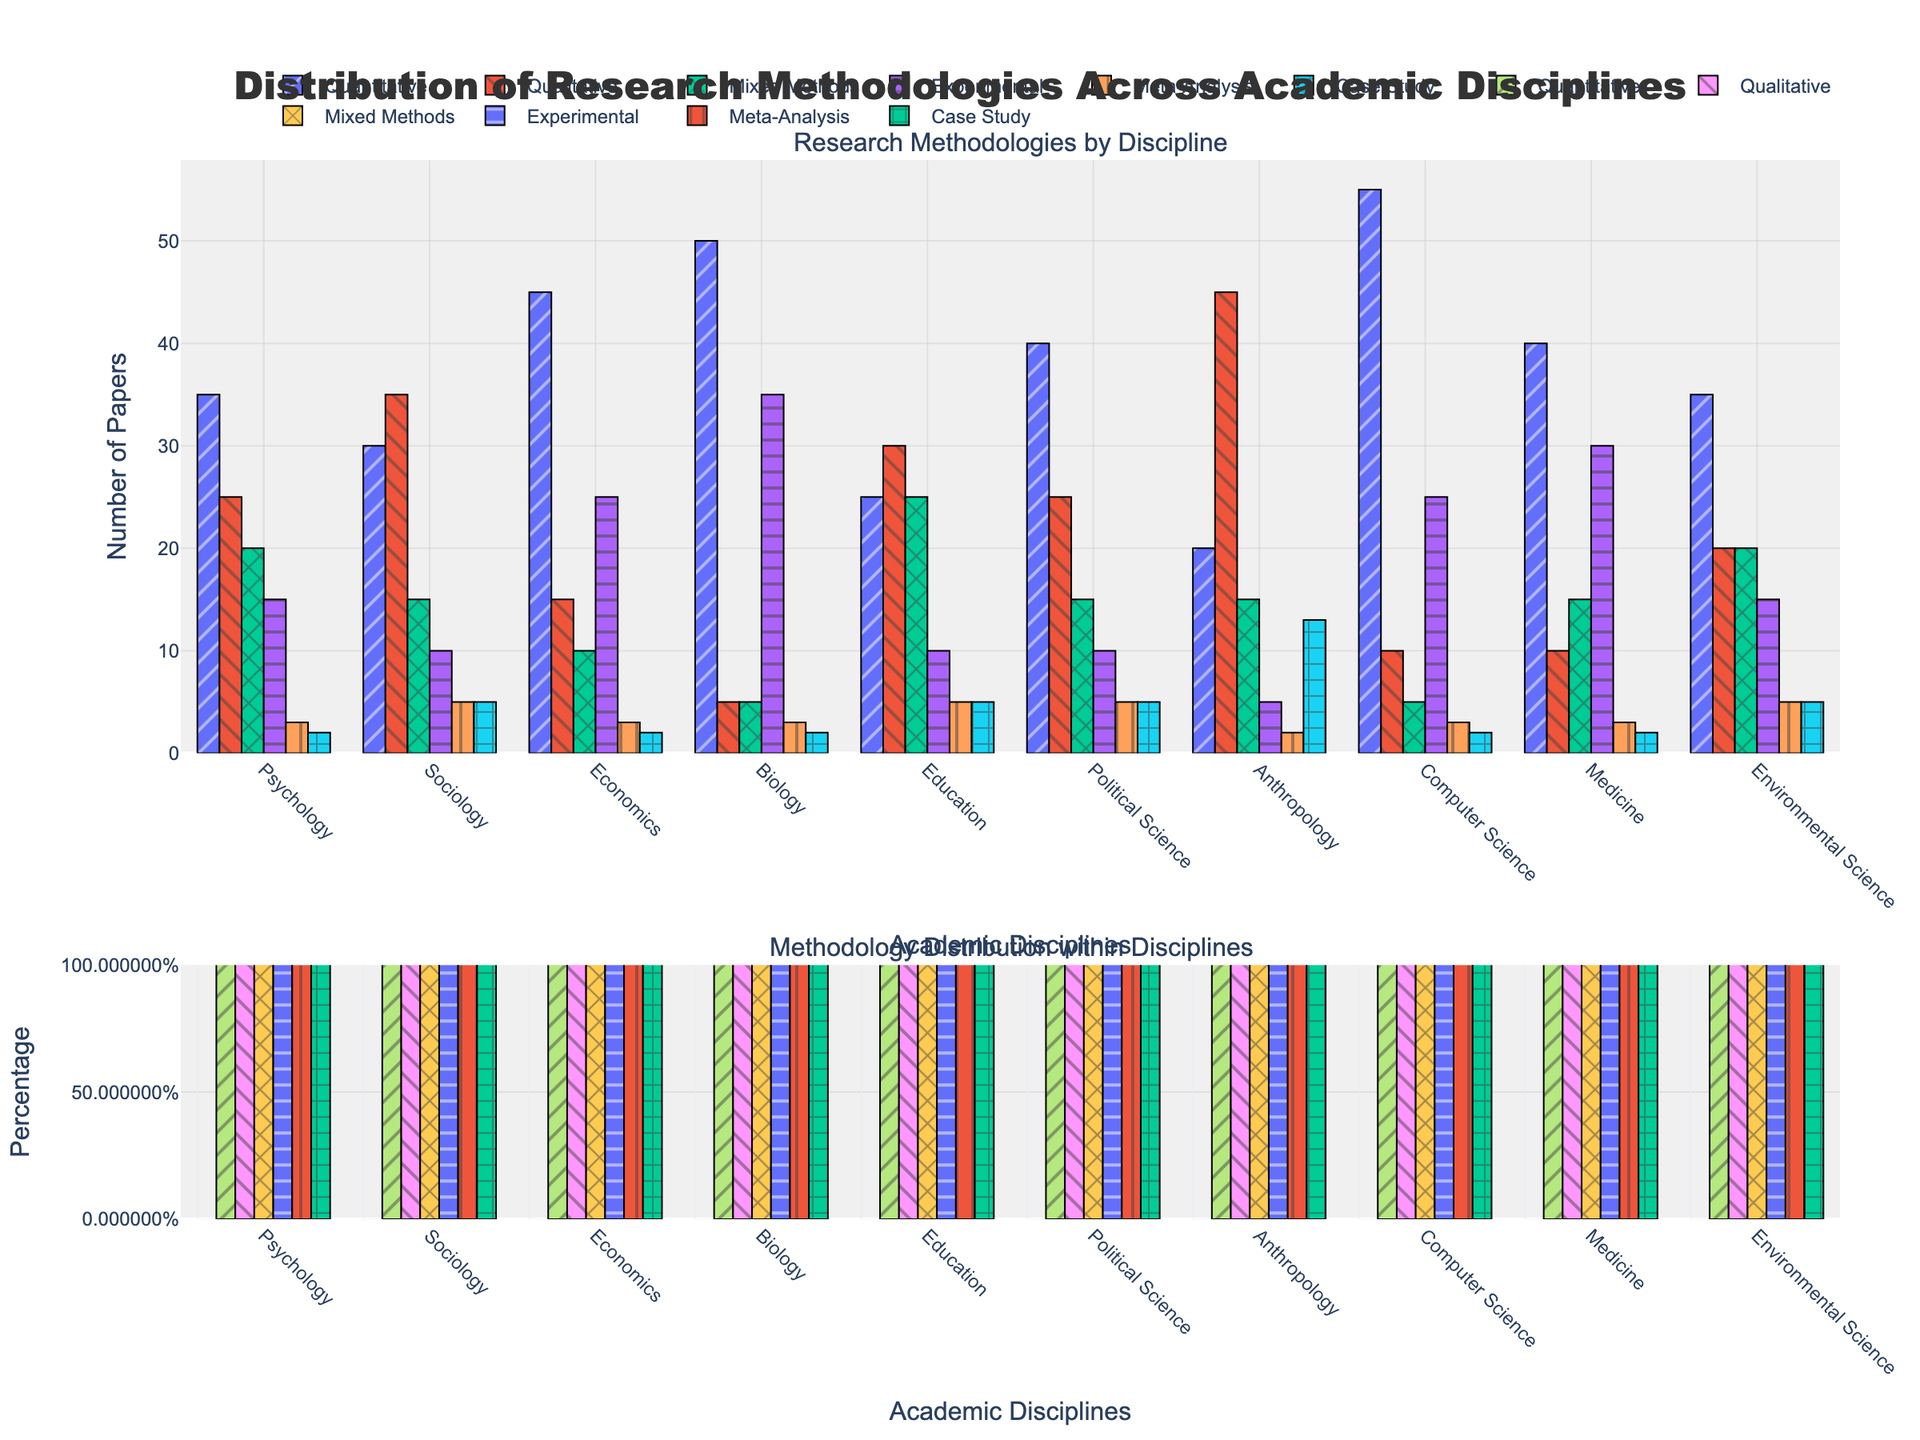What discipline has the highest number of papers using Quantitative methods? By examining the top bar portion, we see that the highest value for Quantitative methodology should have the tallest bar. We find that Computer Science has the highest bar for Quantitative methods at 55 papers.
Answer: Computer Science Which methodology is most common in Anthropology? By comparing the heights of the bars representing different methodologies for Anthropology, it is evident that Qualitative methods have the highest bar, representing 45 papers.
Answer: Qualitative How many more papers in Biology use Experimental methods compared to Mixed Methods? In the Biology category, there are 35 papers using Experimental methods and 5 papers using Mixed Methods. Subtracting these gives 35 - 5 = 30.
Answer: 30 What is the combined number of papers using Qualitative and Meta-Analysis methods in Sociology? For Sociology, there are 35 papers using Qualitative methods and 5 papers using Meta-Analysis. Adding these together gives 35 + 5 = 40.
Answer: 40 Which academic discipline has the lowest number of papers using Case Study methodology? By inspecting the bar heights for Case Study methodology across all disciplines, we note that Psychology, Economics, Biology, Computer Science, and Medicine all have the lowest bar, representing 2 papers each.
Answer: Psychology, Economics, Biology, Computer Science, Medicine Is the number of Quantitative papers in Economics greater than the sum of Qualitative and Experimental papers in Education? In Economics, 45 papers use Quantitative methods. In Education, Qualitative and Experimental account for a sum of 30 + 10 = 40 papers. Since 45 > 40, the statement is true.
Answer: Yes What percentage of papers in Political Science use Mixed Methods? In Political Science, there are 15 papers using Mixed Methods out of a total of 100 papers (sum of all methods). The percentage is calculated as (15/100) = 0.15 or 15%.
Answer: 15% Which discipline has the largest difference in the number of papers using Quantitative and Qualitative methods? By comparing the differences in the values for Quantitative and Qualitative methods in each discipline, the largest difference is found in Computer Science with Quantitative (55) and Qualitative (10). The difference is 55 - 10 = 45.
Answer: Computer Science How does the number of papers using Meta-Analysis in Environmental Science compare to that in Medicine? Both Environmental Science and Medicine show 3 papers using Meta-Analysis, represented by visually identical bar heights.
Answer: They are equal Which discipline uses Experimental methods more frequently: Education or Psychology? Comparing the number of papers using Experimental methods, Psychology has 15 papers while Education has 10 papers. Therefore, Psychology uses Experimental methods more frequently.
Answer: Psychology 